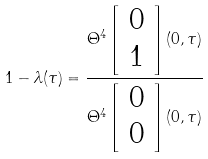<formula> <loc_0><loc_0><loc_500><loc_500>1 - \lambda ( \tau ) = \frac { \Theta ^ { 4 } \left [ \begin{array} { c } 0 \\ 1 \end{array} \right ] ( 0 , \tau ) } { \Theta ^ { 4 } \left [ \begin{array} { c } 0 \\ 0 \end{array} \right ] ( 0 , \tau ) }</formula> 